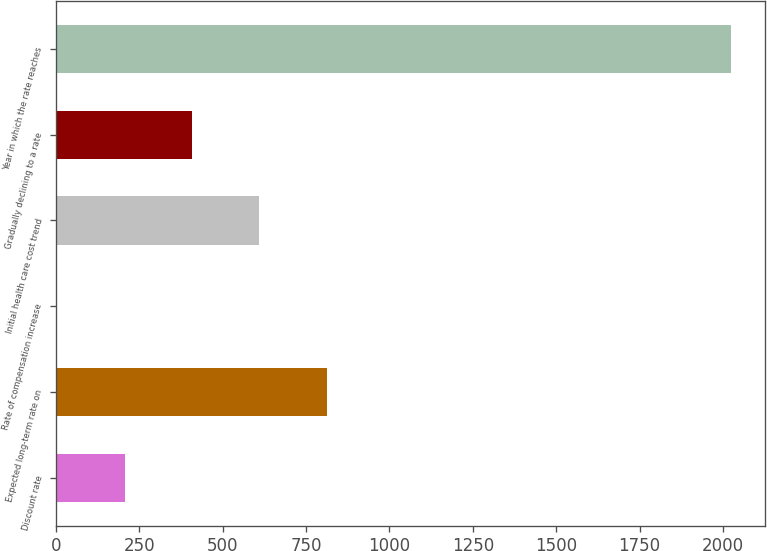<chart> <loc_0><loc_0><loc_500><loc_500><bar_chart><fcel>Discount rate<fcel>Expected long-term rate on<fcel>Rate of compensation increase<fcel>Initial health care cost trend<fcel>Gradually declining to a rate<fcel>Year in which the rate reaches<nl><fcel>205.69<fcel>811.78<fcel>3.66<fcel>609.75<fcel>407.72<fcel>2024<nl></chart> 